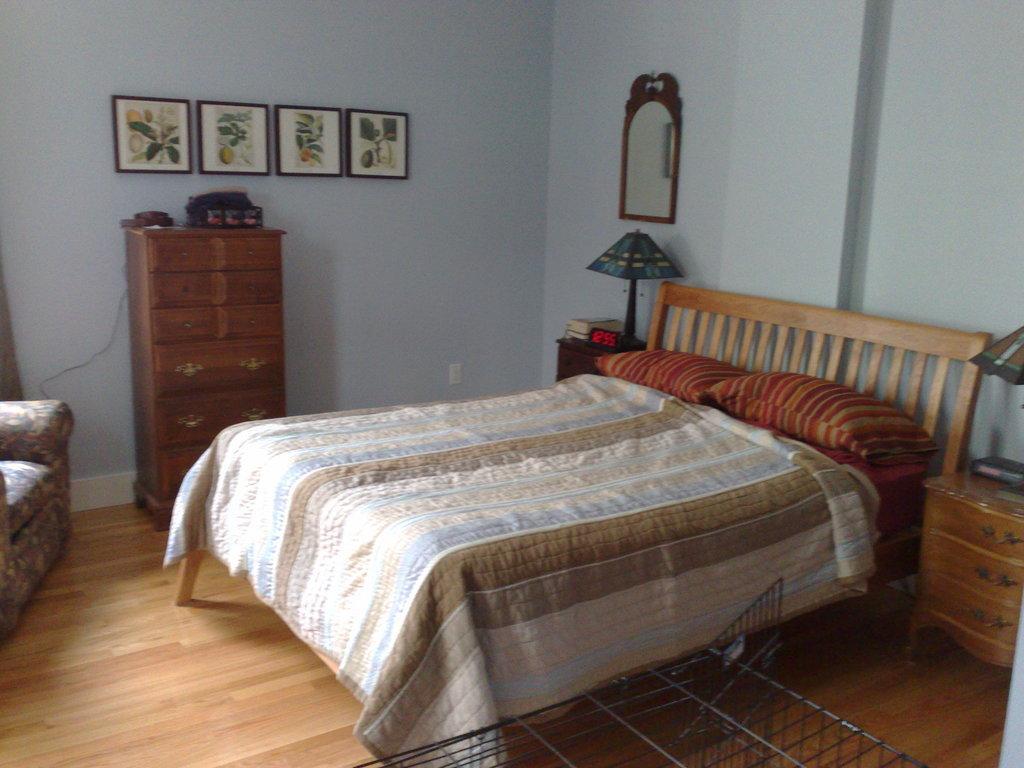Could you give a brief overview of what you see in this image? In this image we can see photo frames, cupboards, bed, pillows, mirror, chair and a wall. 